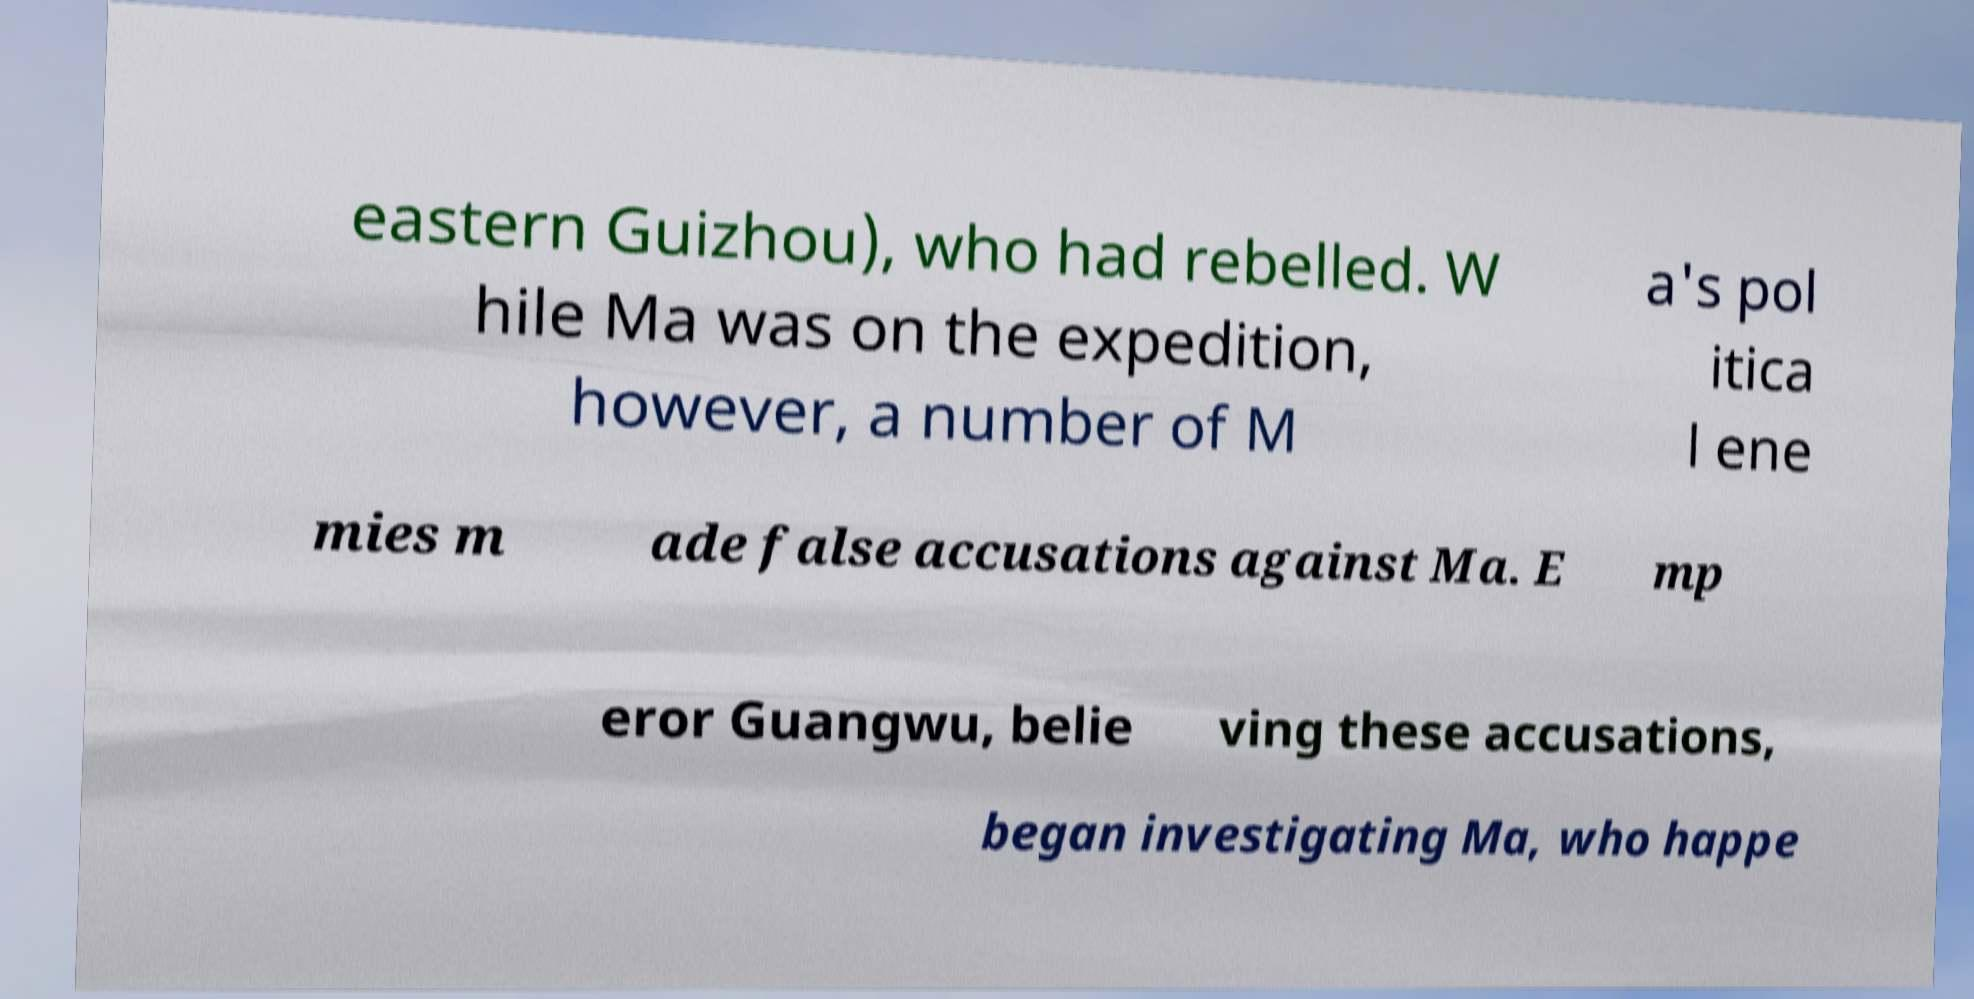Please identify and transcribe the text found in this image. eastern Guizhou), who had rebelled. W hile Ma was on the expedition, however, a number of M a's pol itica l ene mies m ade false accusations against Ma. E mp eror Guangwu, belie ving these accusations, began investigating Ma, who happe 